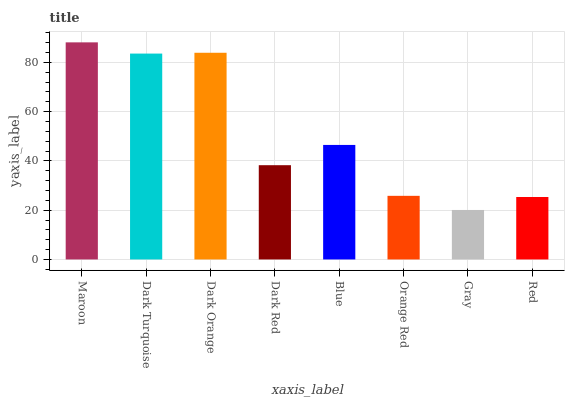Is Gray the minimum?
Answer yes or no. Yes. Is Maroon the maximum?
Answer yes or no. Yes. Is Dark Turquoise the minimum?
Answer yes or no. No. Is Dark Turquoise the maximum?
Answer yes or no. No. Is Maroon greater than Dark Turquoise?
Answer yes or no. Yes. Is Dark Turquoise less than Maroon?
Answer yes or no. Yes. Is Dark Turquoise greater than Maroon?
Answer yes or no. No. Is Maroon less than Dark Turquoise?
Answer yes or no. No. Is Blue the high median?
Answer yes or no. Yes. Is Dark Red the low median?
Answer yes or no. Yes. Is Dark Red the high median?
Answer yes or no. No. Is Orange Red the low median?
Answer yes or no. No. 